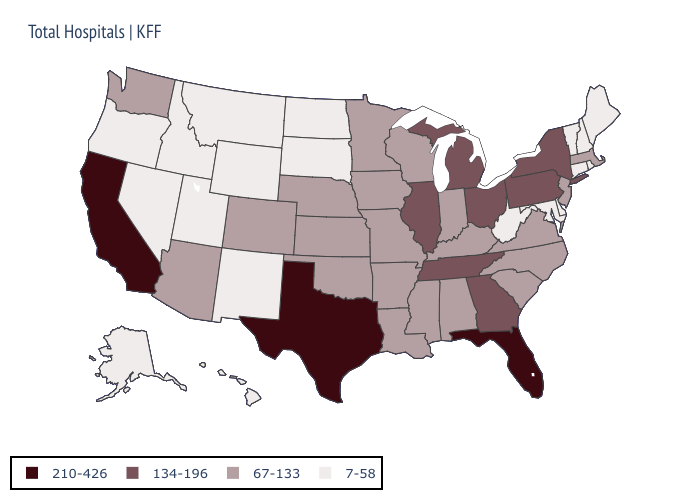Name the states that have a value in the range 210-426?
Be succinct. California, Florida, Texas. Name the states that have a value in the range 7-58?
Give a very brief answer. Alaska, Connecticut, Delaware, Hawaii, Idaho, Maine, Maryland, Montana, Nevada, New Hampshire, New Mexico, North Dakota, Oregon, Rhode Island, South Dakota, Utah, Vermont, West Virginia, Wyoming. Does Ohio have the highest value in the MidWest?
Answer briefly. Yes. Which states have the highest value in the USA?
Quick response, please. California, Florida, Texas. Among the states that border Minnesota , which have the highest value?
Be succinct. Iowa, Wisconsin. What is the highest value in states that border Maine?
Give a very brief answer. 7-58. What is the highest value in states that border Wisconsin?
Give a very brief answer. 134-196. What is the value of Missouri?
Be succinct. 67-133. What is the lowest value in the Northeast?
Write a very short answer. 7-58. What is the highest value in states that border Massachusetts?
Concise answer only. 134-196. Does Indiana have the highest value in the MidWest?
Short answer required. No. What is the highest value in the West ?
Give a very brief answer. 210-426. What is the lowest value in the Northeast?
Give a very brief answer. 7-58. Among the states that border Indiana , does Michigan have the highest value?
Keep it brief. Yes. 